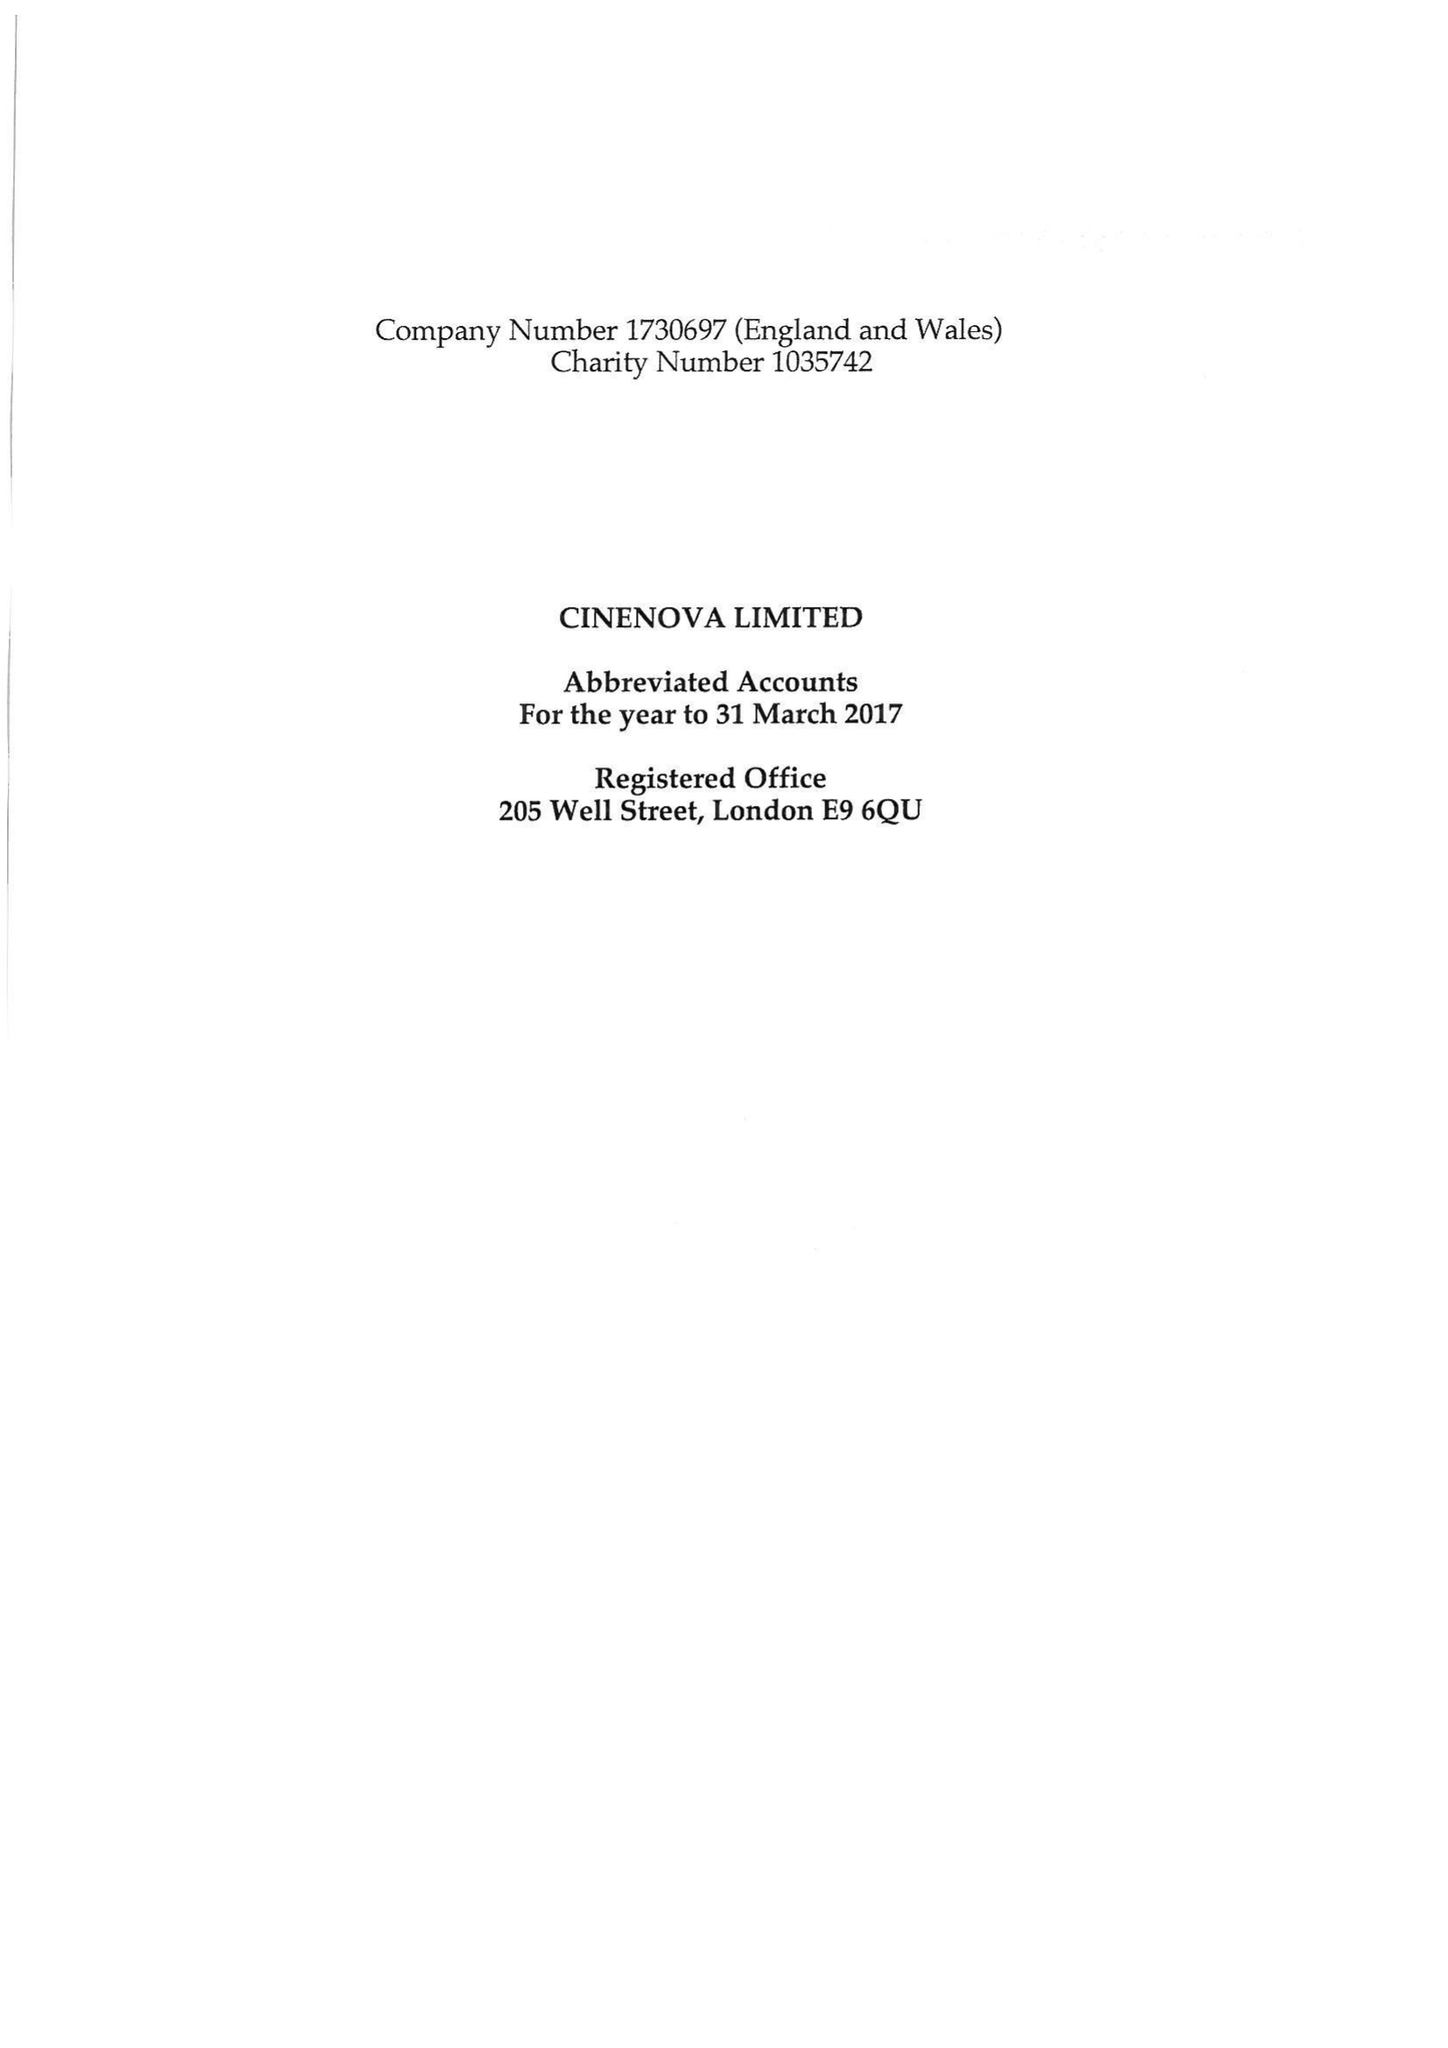What is the value for the charity_number?
Answer the question using a single word or phrase. 1035742 